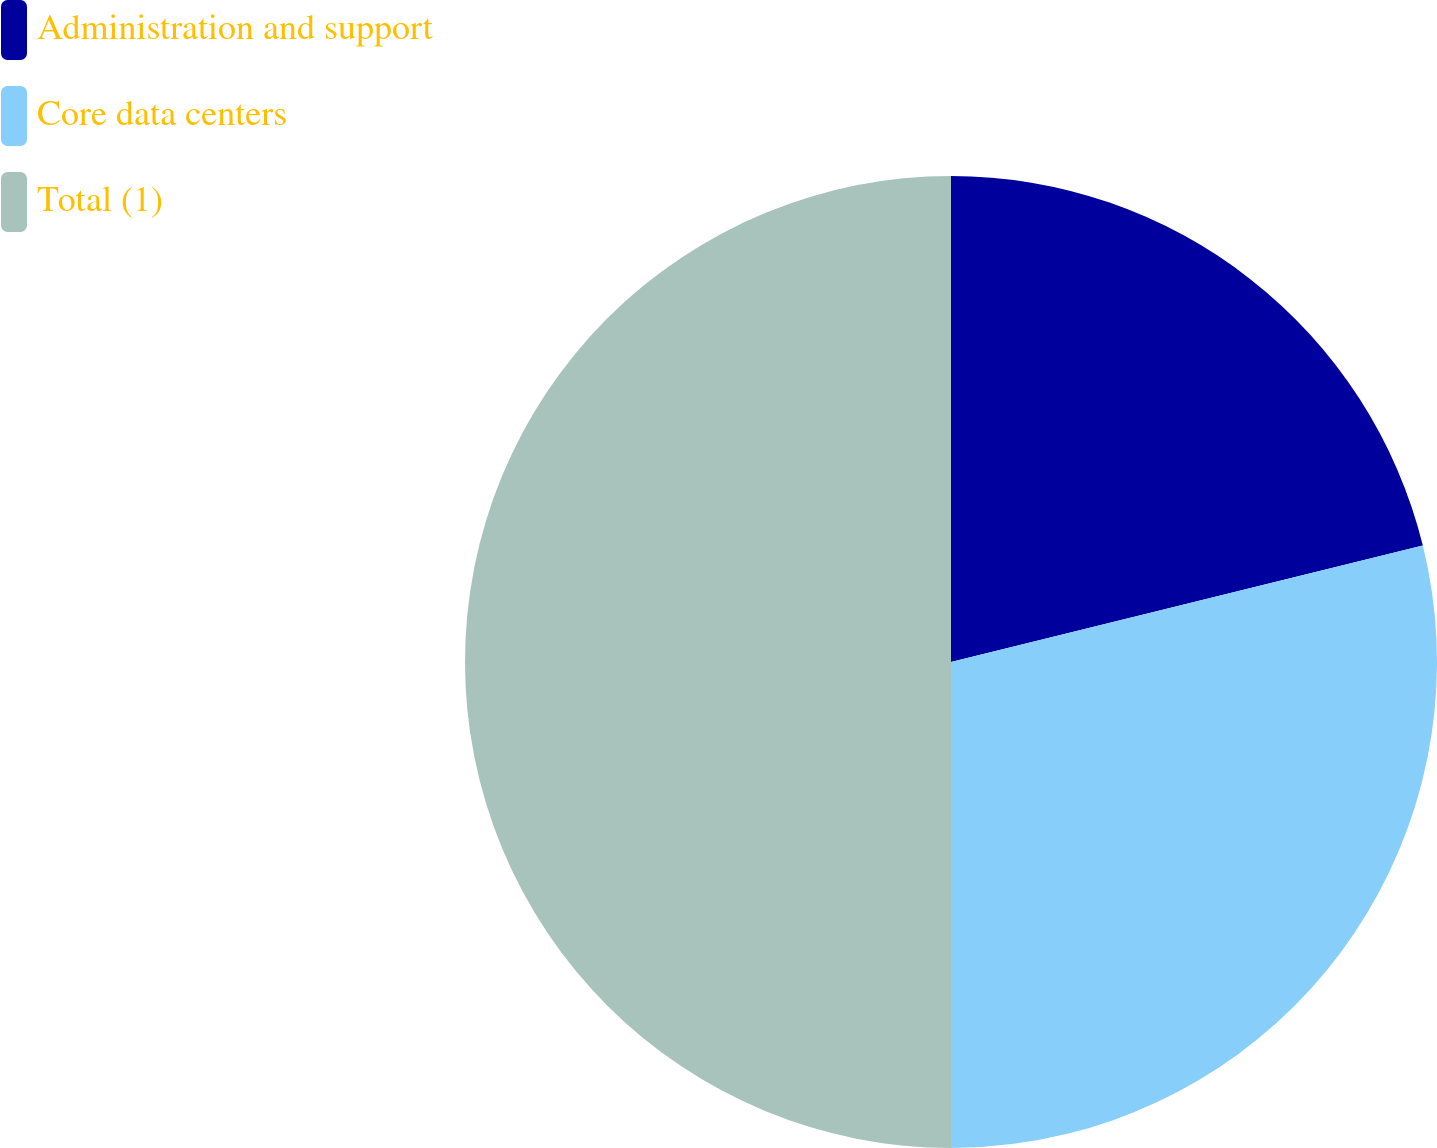<chart> <loc_0><loc_0><loc_500><loc_500><pie_chart><fcel>Administration and support<fcel>Core data centers<fcel>Total (1)<nl><fcel>21.15%<fcel>28.85%<fcel>50.0%<nl></chart> 